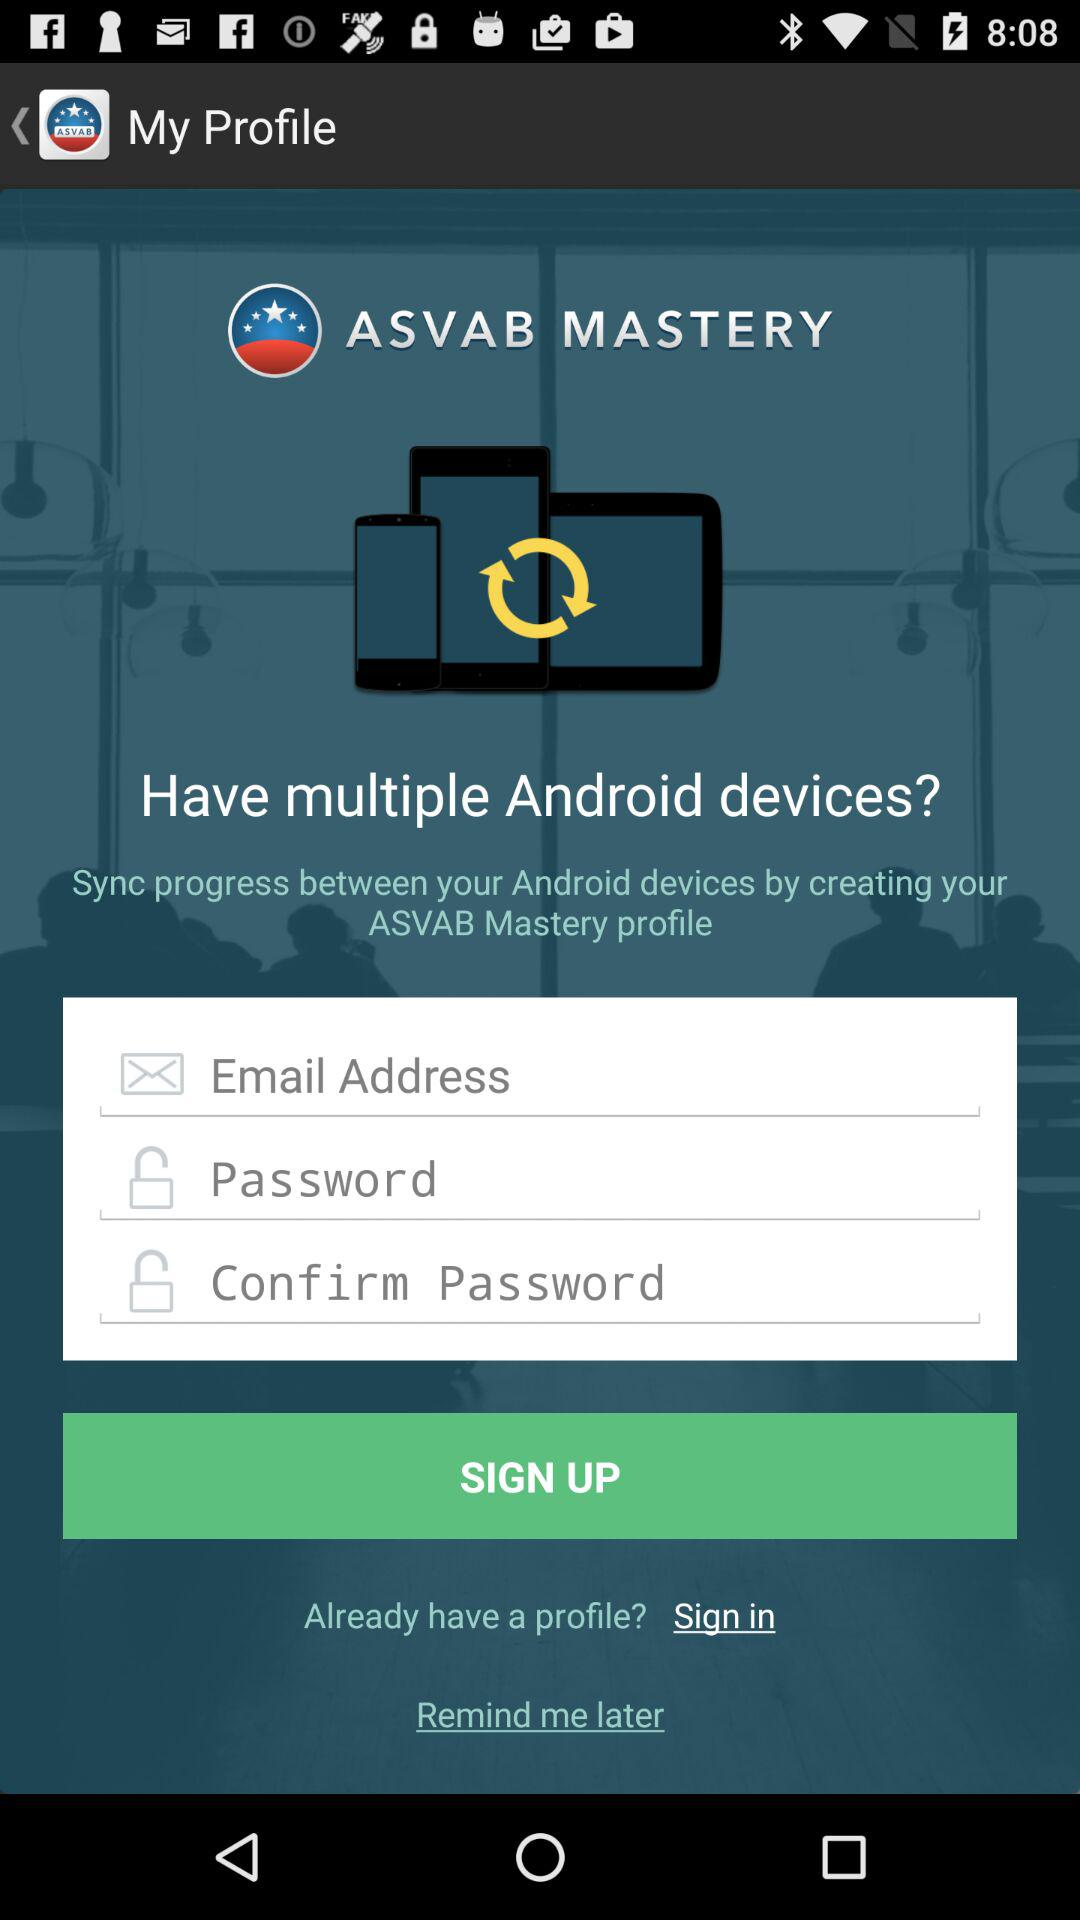How many input fields are there for creating a profile?
Answer the question using a single word or phrase. 3 